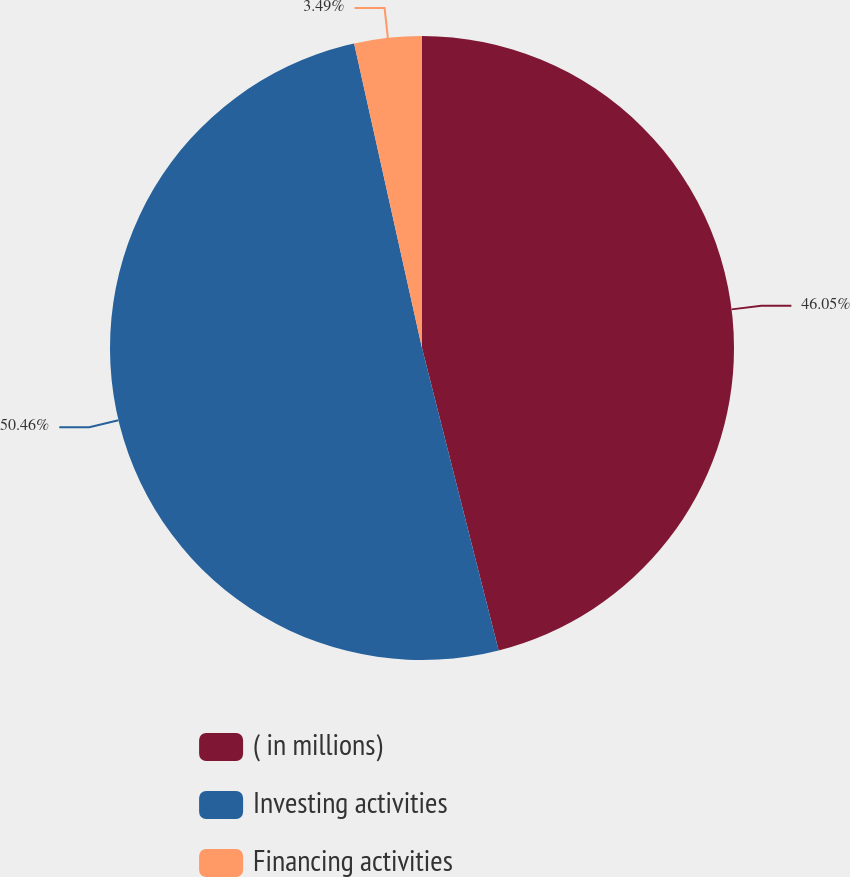Convert chart. <chart><loc_0><loc_0><loc_500><loc_500><pie_chart><fcel>( in millions)<fcel>Investing activities<fcel>Financing activities<nl><fcel>46.05%<fcel>50.46%<fcel>3.49%<nl></chart> 